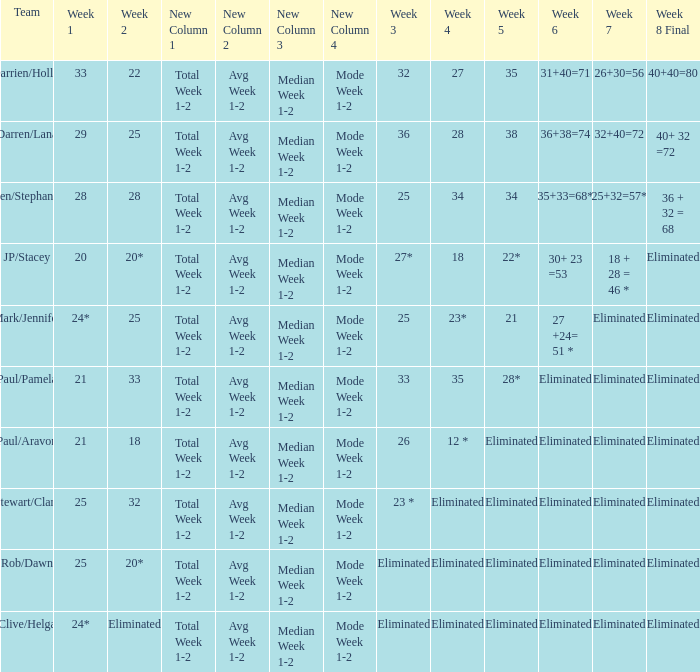Name the week 6 when week 3 is 25 and week 7 is eliminated 27 +24= 51 *. 